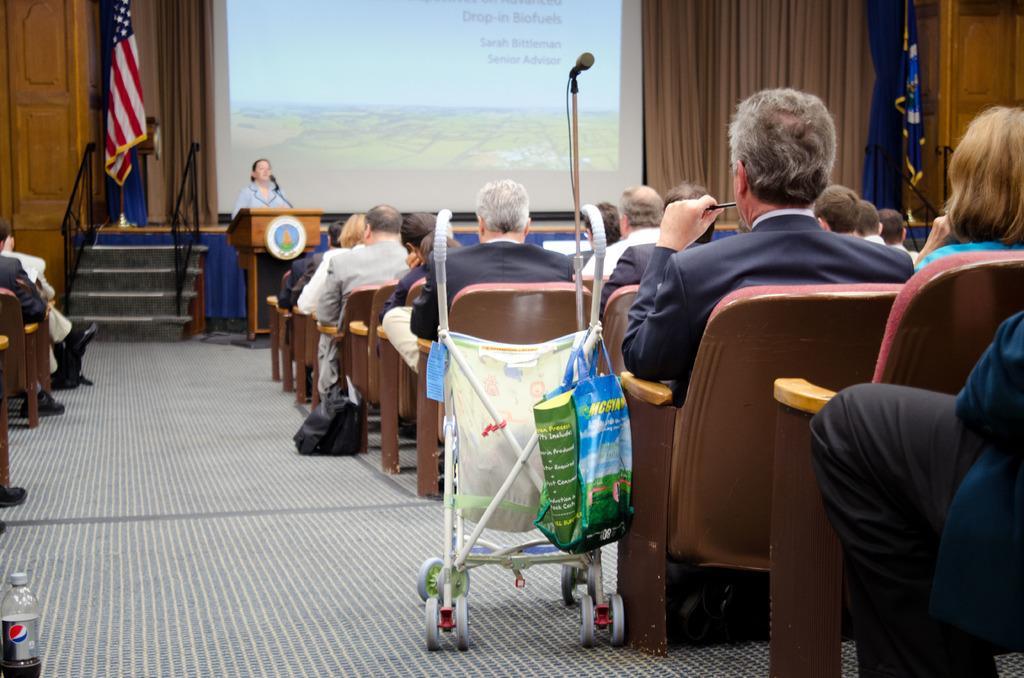Please provide a concise description of this image. In this picture there is a person standing behind the podium and there is a microphone and there is a board on the podium and there are group of people sitting on the chairs. In the middle of the image there is a object and there is a bag on the object and there is a microphone. On the left side of the image there is a staircase and there are handrails and there is a flag. At the back there are curtains and there is a screen and there is text on the screen and there is picture of sky and there is picture of mountain on the screen. At the bottom there is a mat. 